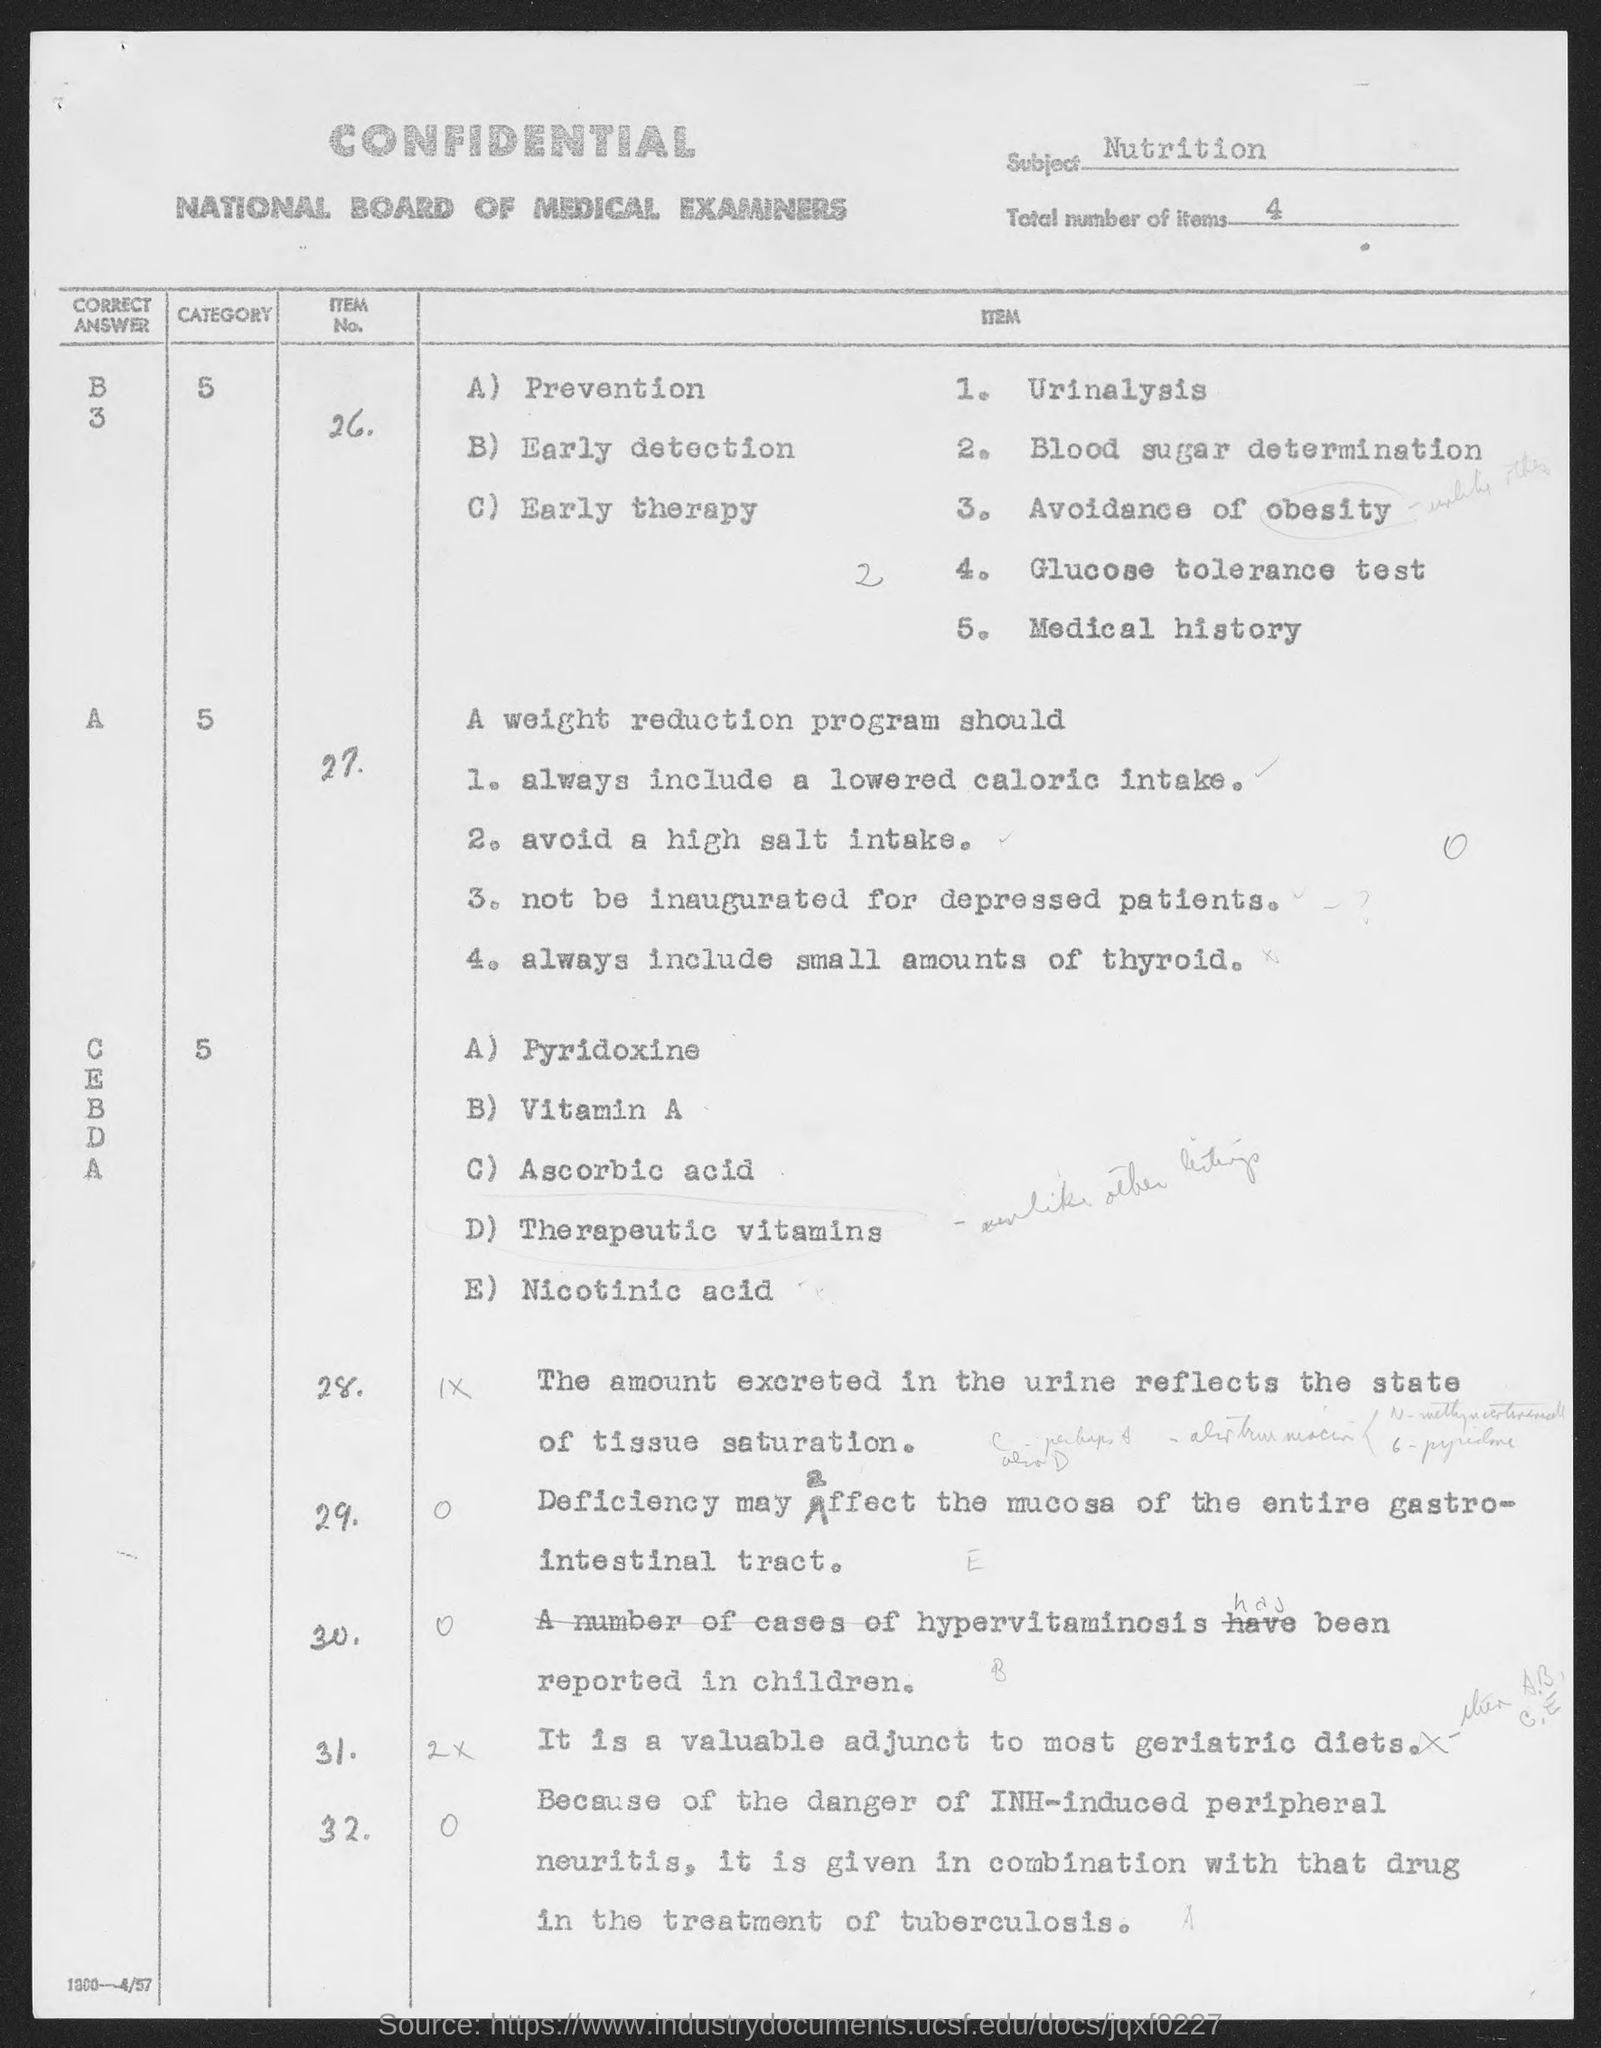Indicate a few pertinent items in this graphic. I declare that the subject is NUTRITION. The total number of items is 4. 